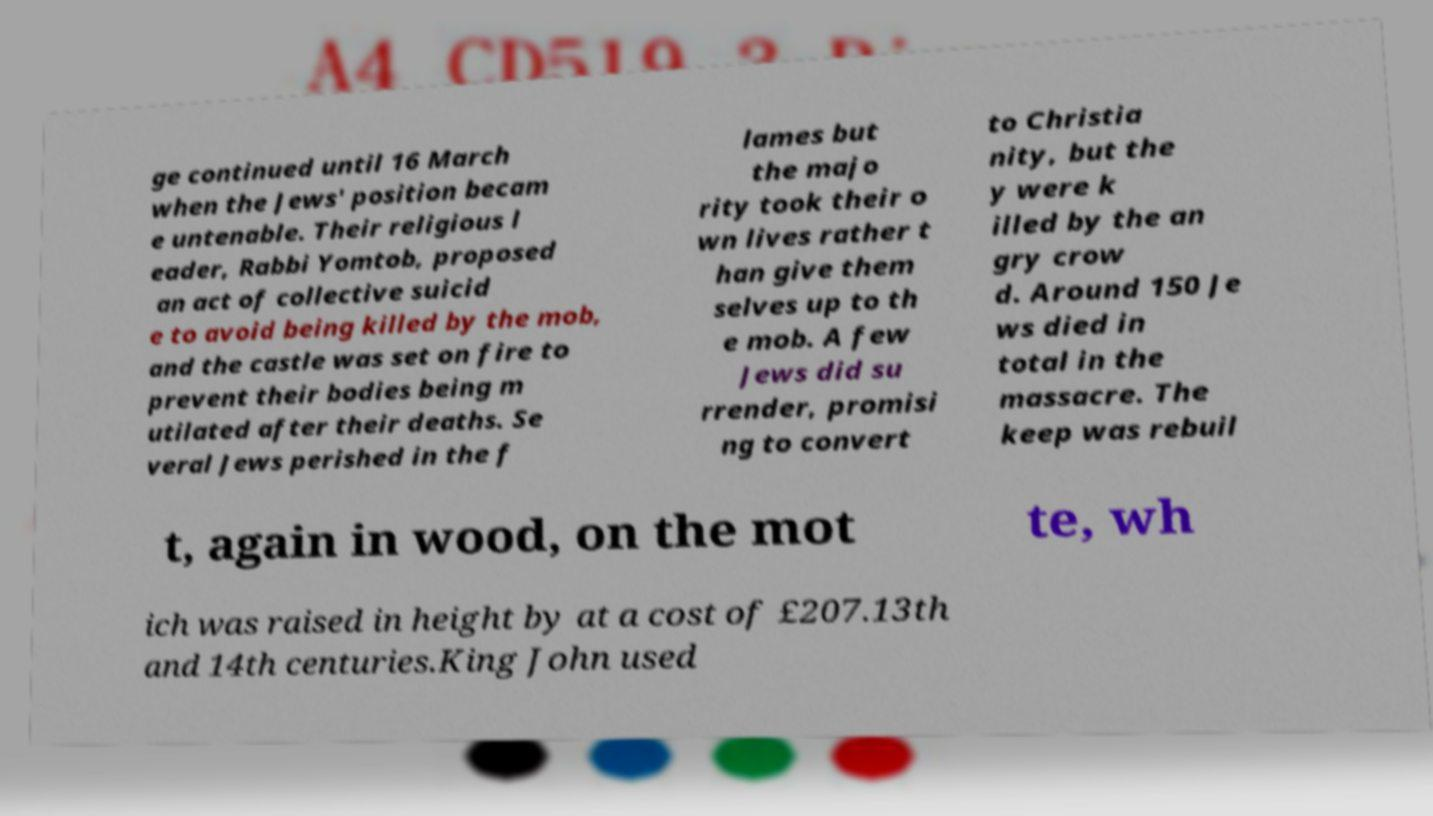Please read and relay the text visible in this image. What does it say? ge continued until 16 March when the Jews' position becam e untenable. Their religious l eader, Rabbi Yomtob, proposed an act of collective suicid e to avoid being killed by the mob, and the castle was set on fire to prevent their bodies being m utilated after their deaths. Se veral Jews perished in the f lames but the majo rity took their o wn lives rather t han give them selves up to th e mob. A few Jews did su rrender, promisi ng to convert to Christia nity, but the y were k illed by the an gry crow d. Around 150 Je ws died in total in the massacre. The keep was rebuil t, again in wood, on the mot te, wh ich was raised in height by at a cost of £207.13th and 14th centuries.King John used 